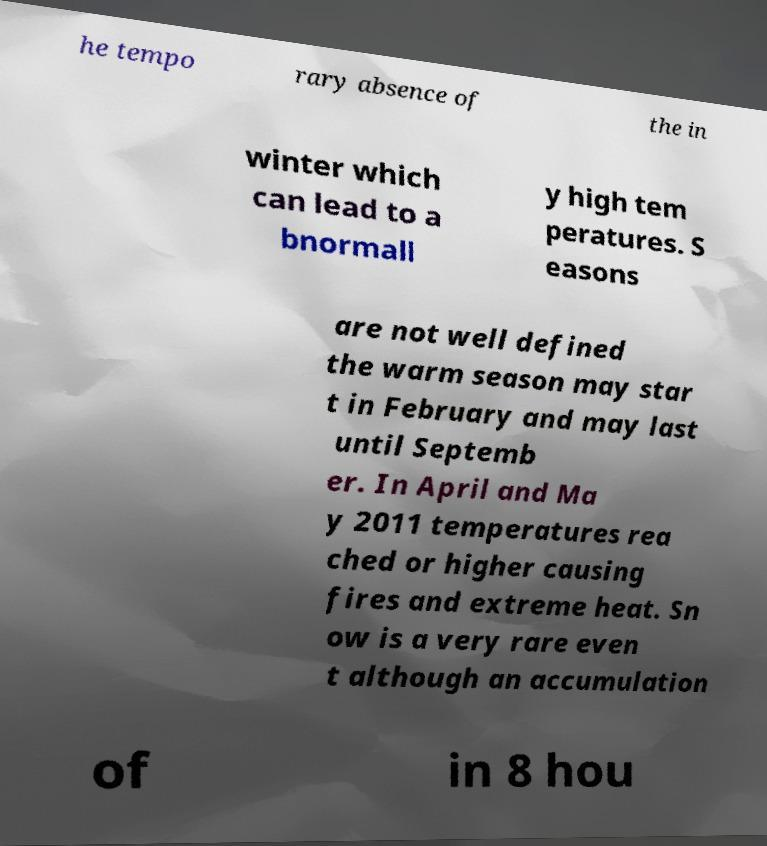Can you read and provide the text displayed in the image?This photo seems to have some interesting text. Can you extract and type it out for me? he tempo rary absence of the in winter which can lead to a bnormall y high tem peratures. S easons are not well defined the warm season may star t in February and may last until Septemb er. In April and Ma y 2011 temperatures rea ched or higher causing fires and extreme heat. Sn ow is a very rare even t although an accumulation of in 8 hou 